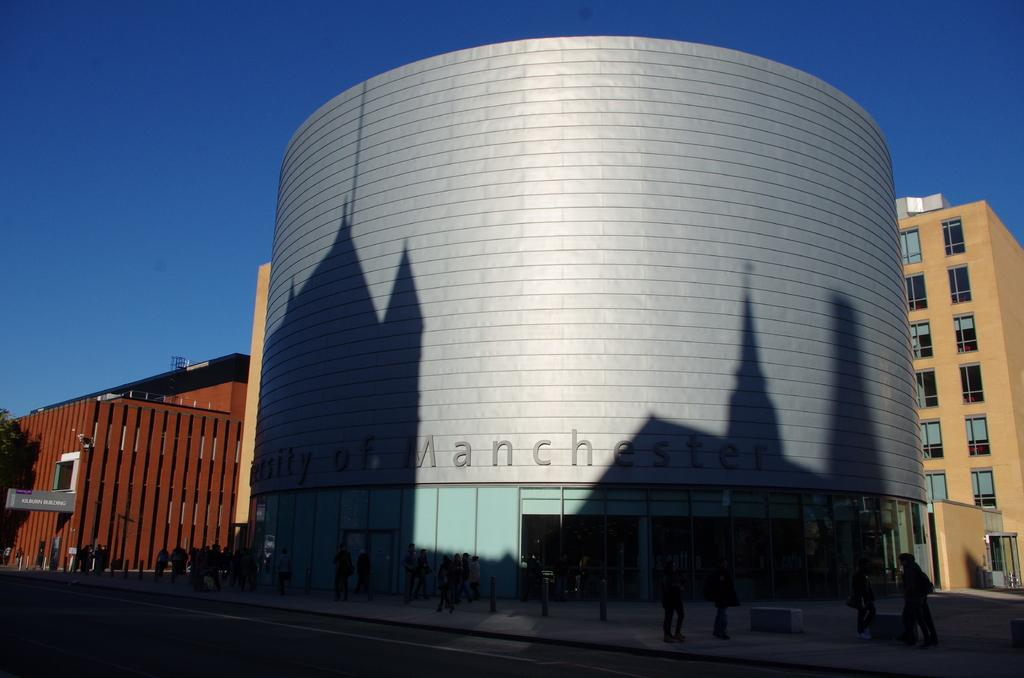What type of structures can be seen in the image? There are buildings in the image. Who or what else is present in the image? There are people and a board in the image. What type of vegetation is visible in the image? There are trees in the image. What can be seen in the distance in the image? The sky is visible in the background of the image. How many dimes are scattered on the ground in the image? There are no dimes present in the image. What month is depicted in the image? The image does not depict a specific month; it only shows buildings, people, a board, trees, and the sky. 